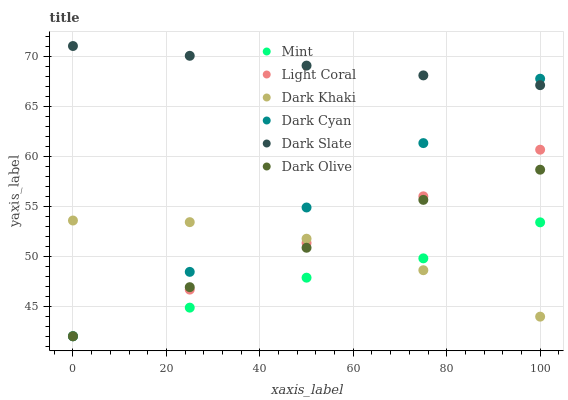Does Mint have the minimum area under the curve?
Answer yes or no. Yes. Does Dark Slate have the maximum area under the curve?
Answer yes or no. Yes. Does Dark Olive have the minimum area under the curve?
Answer yes or no. No. Does Dark Olive have the maximum area under the curve?
Answer yes or no. No. Is Dark Cyan the smoothest?
Answer yes or no. Yes. Is Dark Khaki the roughest?
Answer yes or no. Yes. Is Dark Olive the smoothest?
Answer yes or no. No. Is Dark Olive the roughest?
Answer yes or no. No. Does Dark Olive have the lowest value?
Answer yes or no. Yes. Does Dark Slate have the lowest value?
Answer yes or no. No. Does Dark Slate have the highest value?
Answer yes or no. Yes. Does Dark Olive have the highest value?
Answer yes or no. No. Is Light Coral less than Dark Slate?
Answer yes or no. Yes. Is Dark Slate greater than Light Coral?
Answer yes or no. Yes. Does Mint intersect Dark Khaki?
Answer yes or no. Yes. Is Mint less than Dark Khaki?
Answer yes or no. No. Is Mint greater than Dark Khaki?
Answer yes or no. No. Does Light Coral intersect Dark Slate?
Answer yes or no. No. 